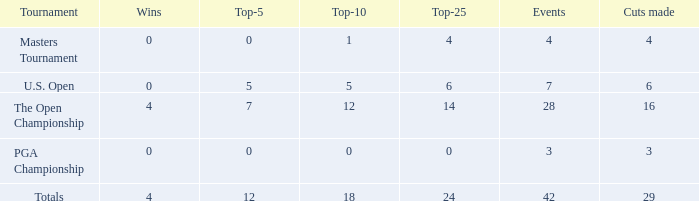What are the highest wins with cuts smaller than 6, events of 4 and a top-5 smaller than 0? None. 